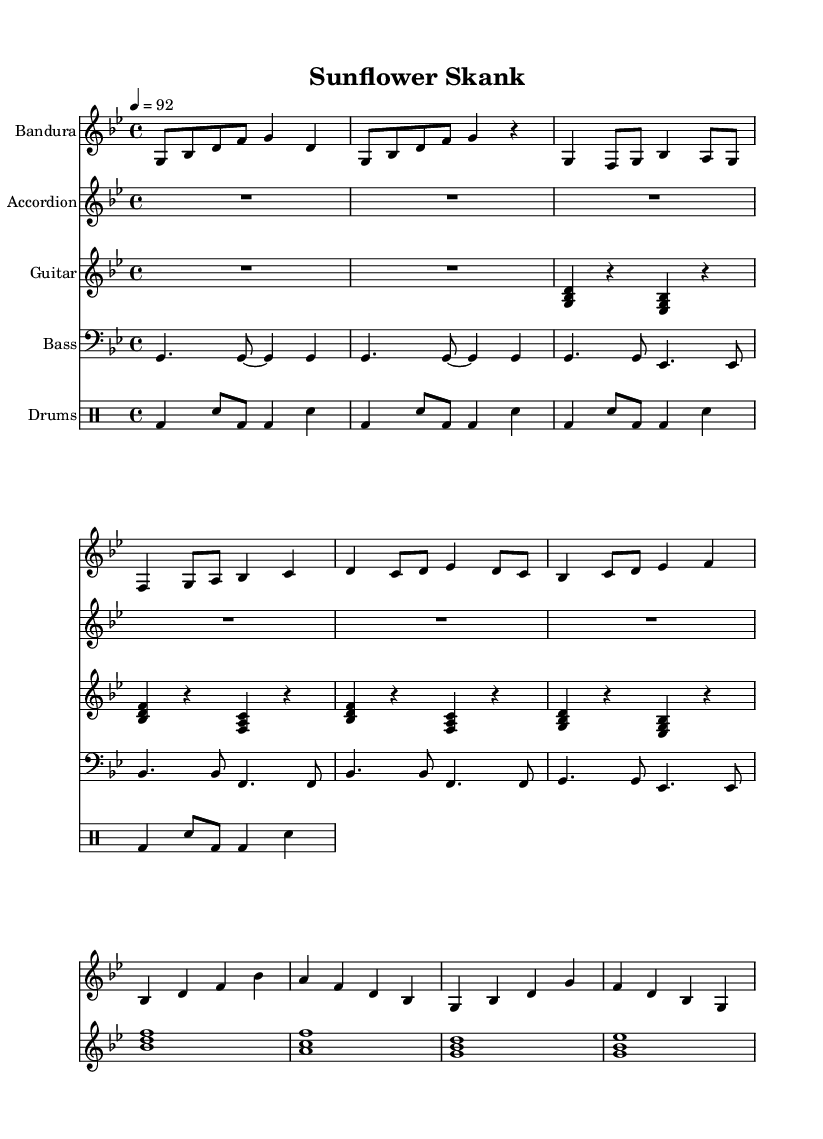What is the key signature of this music? The key signature is G minor, as indicated by the one flat shown in the key signature at the beginning of the score. This affects the notes throughout the piece.
Answer: G minor What is the time signature of this music? The time signature is 4/4, which is indicated at the beginning of the score. This means there are four beats in each measure and the quarter note gets one beat.
Answer: 4/4 What is the tempo marking of this music? The tempo marking shows "4 = 92," indicating the piece should be played at a speed of 92 beats per minute with each quarter note receiving one beat.
Answer: 92 How many bars are in the chorus section? By counting the measures in the chorus section, we see there are four distinct measures, combining the musical phrases that repeat within that section.
Answer: 4 What instruments are used in this arrangement? There are four instruments indicated in the score: Bandura, Accordion, Guitar, and Bass, along with a Drum staff. Each has its own staff showing the respective musical lines.
Answer: Bandura, Accordion, Guitar, Bass, Drums Is there a rhythmic pattern typical to Reggae found in the drum part? The drum part features a straightforward kick-snare pattern typical of Reggae, characterized by the bass drum (bd) on beats one and three and the snare (sn) on beats two and four, giving it a backbeat feel.
Answer: Yes 